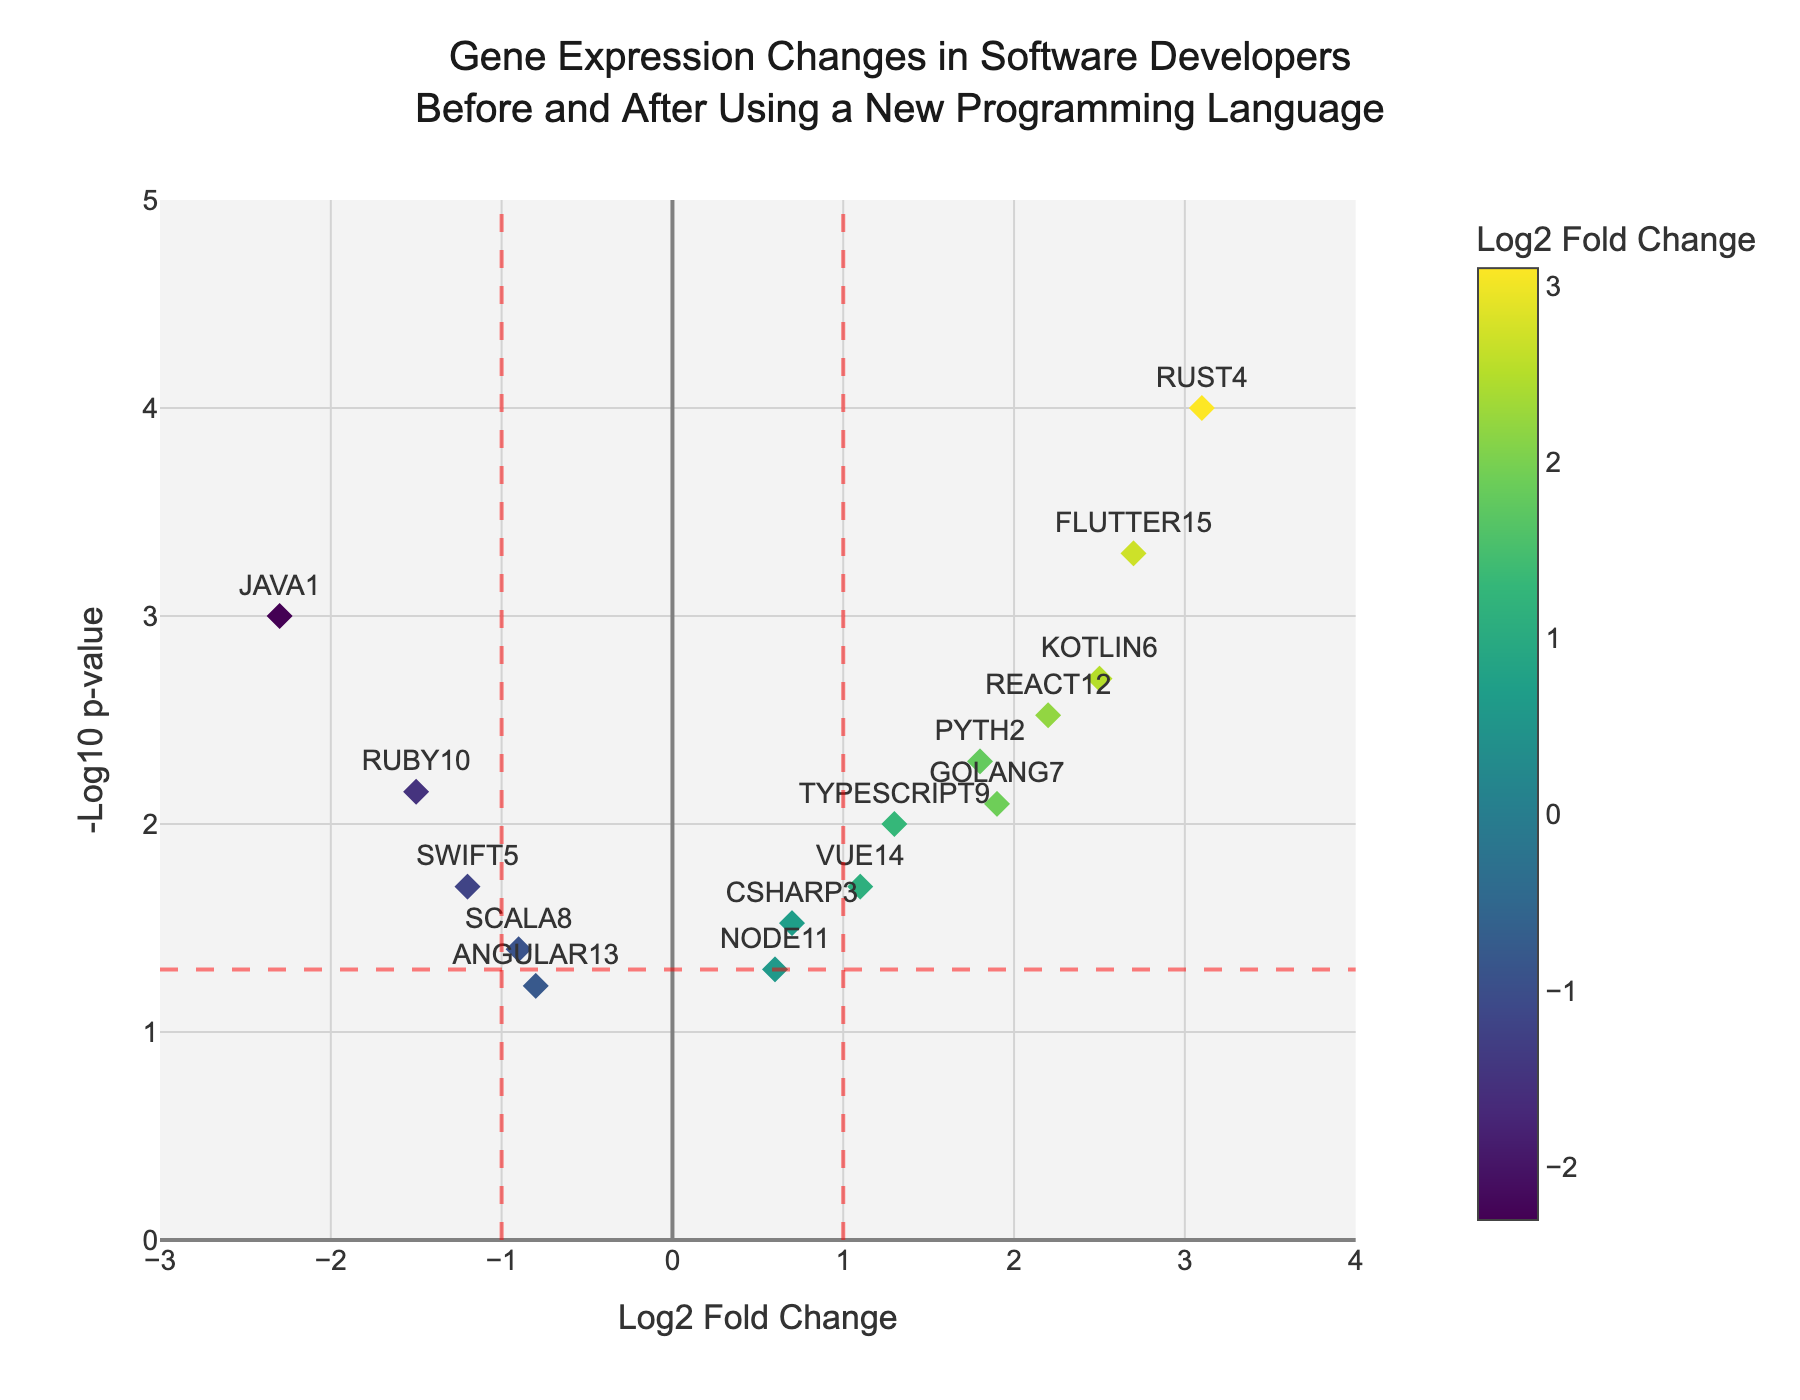Which gene has the highest -log10 p-value? Look for the gene with the highest y-axis value in the figure. This is the one with the largest -log10 p-value.
Answer: RUST4 What is the Log2 Fold Change for the gene KOTLIN6? Find the position of KOTLIN6 on the plot. Its corresponding x-axis value gives the Log2 Fold Change.
Answer: 2.5 Which genes are considered significantly differentially expressed? Genes with p-value less than 0.05 are significant. This is represented by points above the horizontal red line.
Answer: JAVA1, PYTH2, RUST4, SWIFT5, KOTLIN6, GOLANG7, RUBY10, REACT12, VUE14, FLUTTER15 What are the genes with the largest positive and negative Log2 Fold Change? Identify the points furthest to the right (positive) and to the left (negative) on the x-axis.
Answer: RUST4 (positive) and JAVA1 (negative) How many genes have a Log2 Fold Change greater than 1 and are statistically significant? Count the points to the right of the vertical red line at x=1 and above the horizontal red line.
Answer: 5 Which gene has the smallest p-value and what is its Log2 Fold Change? The smallest p-value corresponds to the highest -log10 p-value. Identify that point and its x-axis value gives the Log2 Fold Change.
Answer: RUST4, 3.1 Which gene is closest to the threshold for statistical significance (p-value = 0.05)? Look for the point closest to the horizontal red line.
Answer: ANGULAR13 How does the Log2 Fold Change of PYTH2 compare to that of REACT12? Locate both genes on the x-axis and compare their positions.
Answer: PYTH2 is slightly lower than REACT12 What is the color scheme used to represent Log2 Fold Change? Examine the color bar provided in the figure to understand the range of colors.
Answer: Viridis How many genes have a negative Log2 Fold Change and are statistically significant? Count the points to the left of the vertical red line at x = -1 and above the horizontal red line.
Answer: 2 